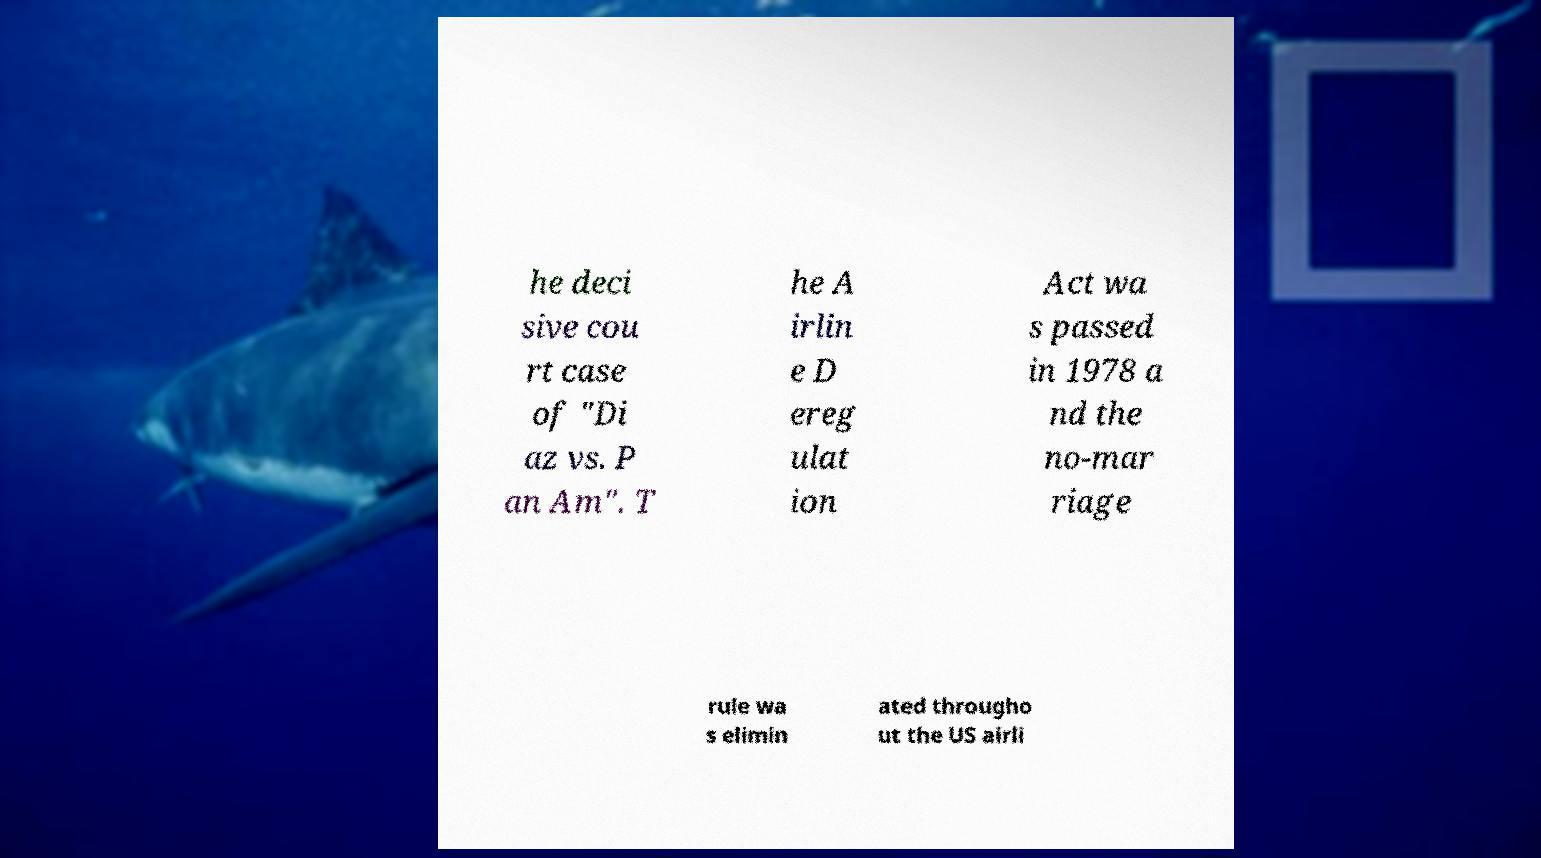Can you accurately transcribe the text from the provided image for me? he deci sive cou rt case of "Di az vs. P an Am". T he A irlin e D ereg ulat ion Act wa s passed in 1978 a nd the no-mar riage rule wa s elimin ated througho ut the US airli 